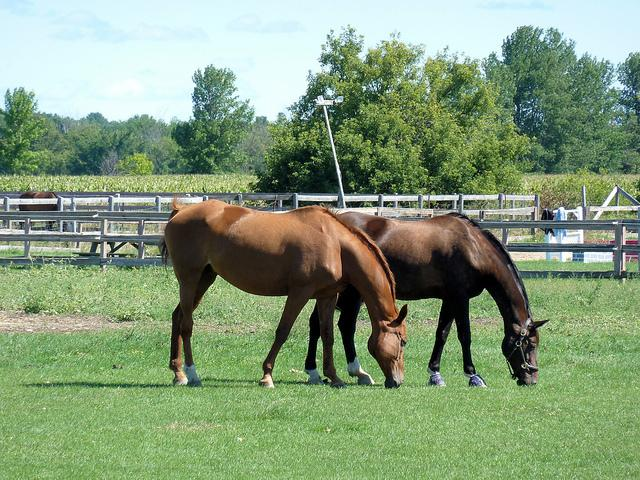Who likely owns these horses? Please explain your reasoning. rancher. The horses are on a ranch. 